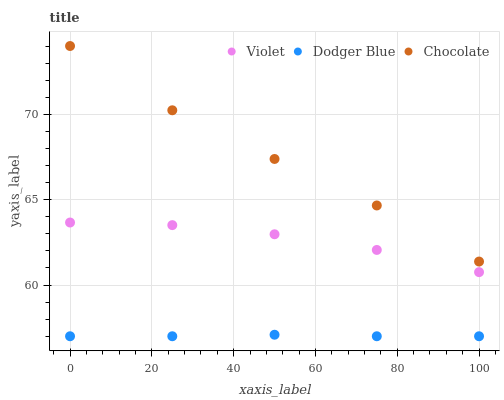Does Dodger Blue have the minimum area under the curve?
Answer yes or no. Yes. Does Chocolate have the maximum area under the curve?
Answer yes or no. Yes. Does Violet have the minimum area under the curve?
Answer yes or no. No. Does Violet have the maximum area under the curve?
Answer yes or no. No. Is Dodger Blue the smoothest?
Answer yes or no. Yes. Is Chocolate the roughest?
Answer yes or no. Yes. Is Violet the smoothest?
Answer yes or no. No. Is Violet the roughest?
Answer yes or no. No. Does Dodger Blue have the lowest value?
Answer yes or no. Yes. Does Violet have the lowest value?
Answer yes or no. No. Does Chocolate have the highest value?
Answer yes or no. Yes. Does Violet have the highest value?
Answer yes or no. No. Is Violet less than Chocolate?
Answer yes or no. Yes. Is Chocolate greater than Dodger Blue?
Answer yes or no. Yes. Does Violet intersect Chocolate?
Answer yes or no. No. 